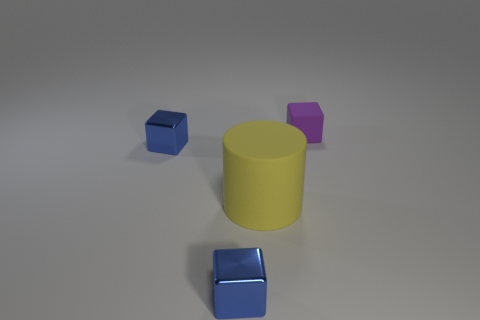Is there anything else that is the same size as the yellow matte object?
Give a very brief answer. No. There is a blue object that is to the right of the blue metal thing that is behind the tiny blue metal block in front of the yellow matte object; what size is it?
Keep it short and to the point. Small. There is a small purple object; is its shape the same as the blue metallic thing behind the big yellow matte object?
Provide a short and direct response. Yes. What number of matte things are either yellow objects or tiny things?
Your answer should be compact. 2. Are there fewer large yellow objects that are on the right side of the purple matte cube than cylinders that are in front of the large yellow cylinder?
Provide a succinct answer. No. Is there a shiny block that is to the left of the rubber object that is in front of the matte cube behind the large yellow thing?
Ensure brevity in your answer.  Yes. There is a blue metallic thing that is in front of the yellow object; does it have the same shape as the purple object behind the big cylinder?
Offer a very short reply. Yes. Are the small thing that is on the right side of the large yellow rubber thing and the cube in front of the yellow rubber object made of the same material?
Ensure brevity in your answer.  No. The matte object that is on the left side of the small rubber block is what color?
Your answer should be compact. Yellow. Are there more small objects left of the small purple rubber thing than metal things to the right of the large yellow cylinder?
Ensure brevity in your answer.  Yes. 